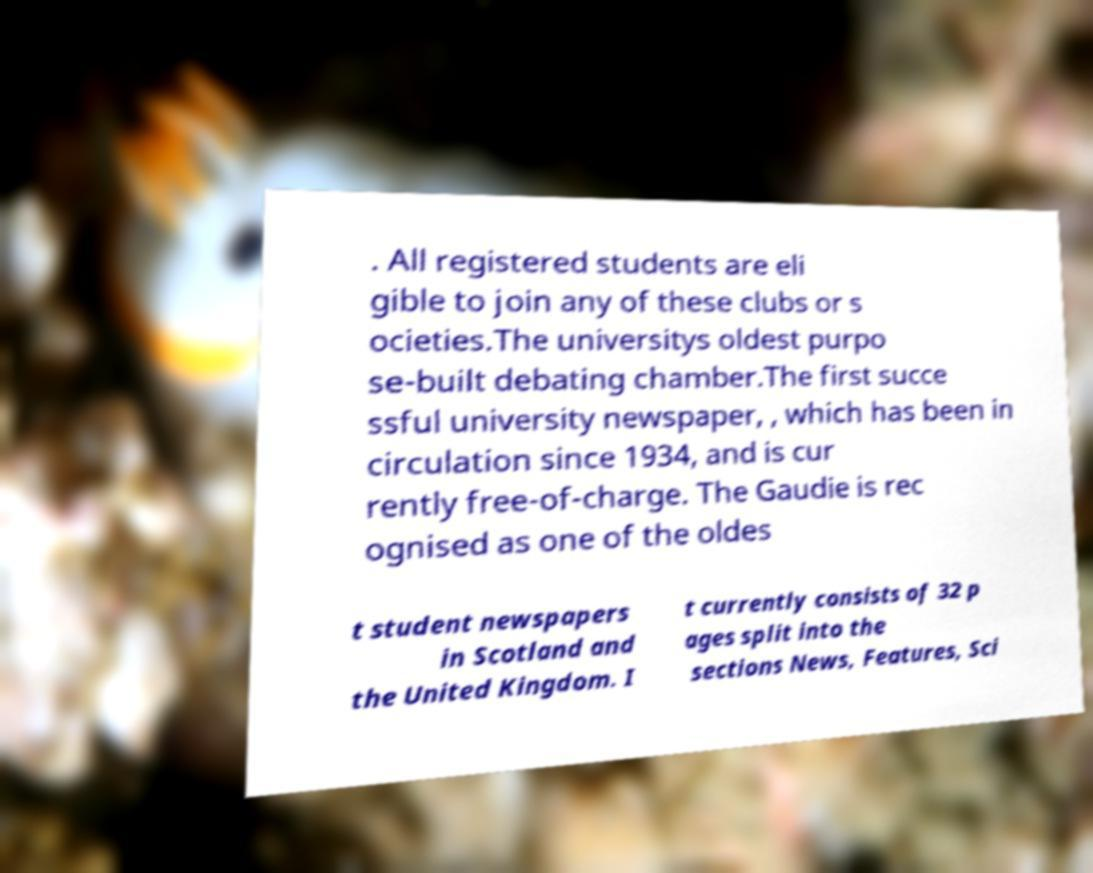What messages or text are displayed in this image? I need them in a readable, typed format. . All registered students are eli gible to join any of these clubs or s ocieties.The universitys oldest purpo se-built debating chamber.The first succe ssful university newspaper, , which has been in circulation since 1934, and is cur rently free-of-charge. The Gaudie is rec ognised as one of the oldes t student newspapers in Scotland and the United Kingdom. I t currently consists of 32 p ages split into the sections News, Features, Sci 